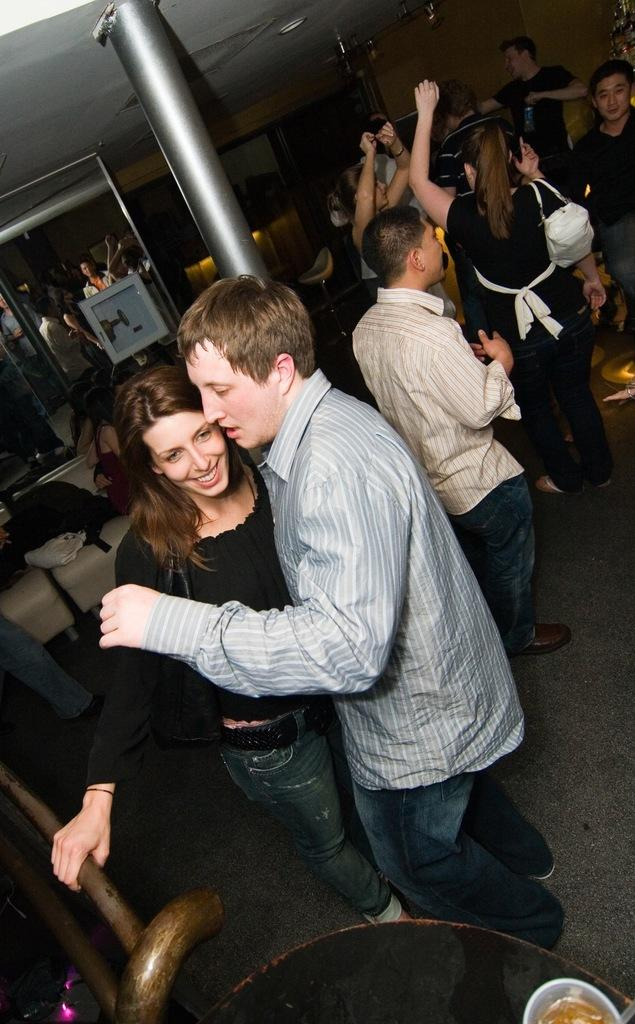What are the people in the image doing? The people in the image are dancing. What can be found on the couch in the image? There are things on the couch in the image. Can you describe a specific feature of the room in the image? There is a pillar in the image. What type of sponge is being used to clean the floor in the image? There is no sponge or cleaning activity visible in the image. What type of competition is taking place in the image? There is no competition present in the image; people are dancing. 